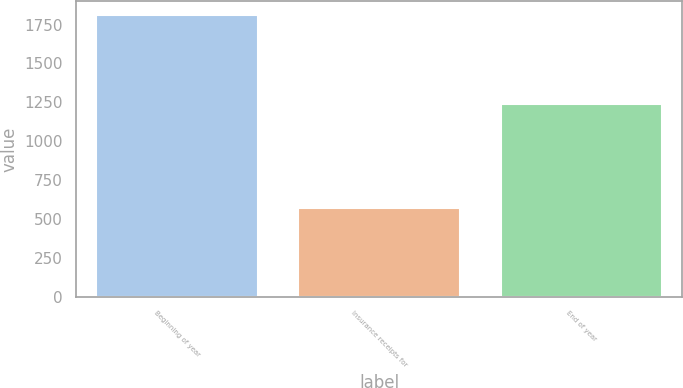Convert chart to OTSL. <chart><loc_0><loc_0><loc_500><loc_500><bar_chart><fcel>Beginning of year<fcel>Insurance receipts for<fcel>End of year<nl><fcel>1811<fcel>573<fcel>1238<nl></chart> 